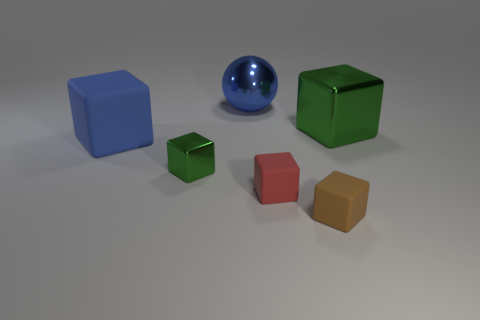What is the material of the small block to the right of the small matte block that is on the left side of the tiny brown matte object? rubber 